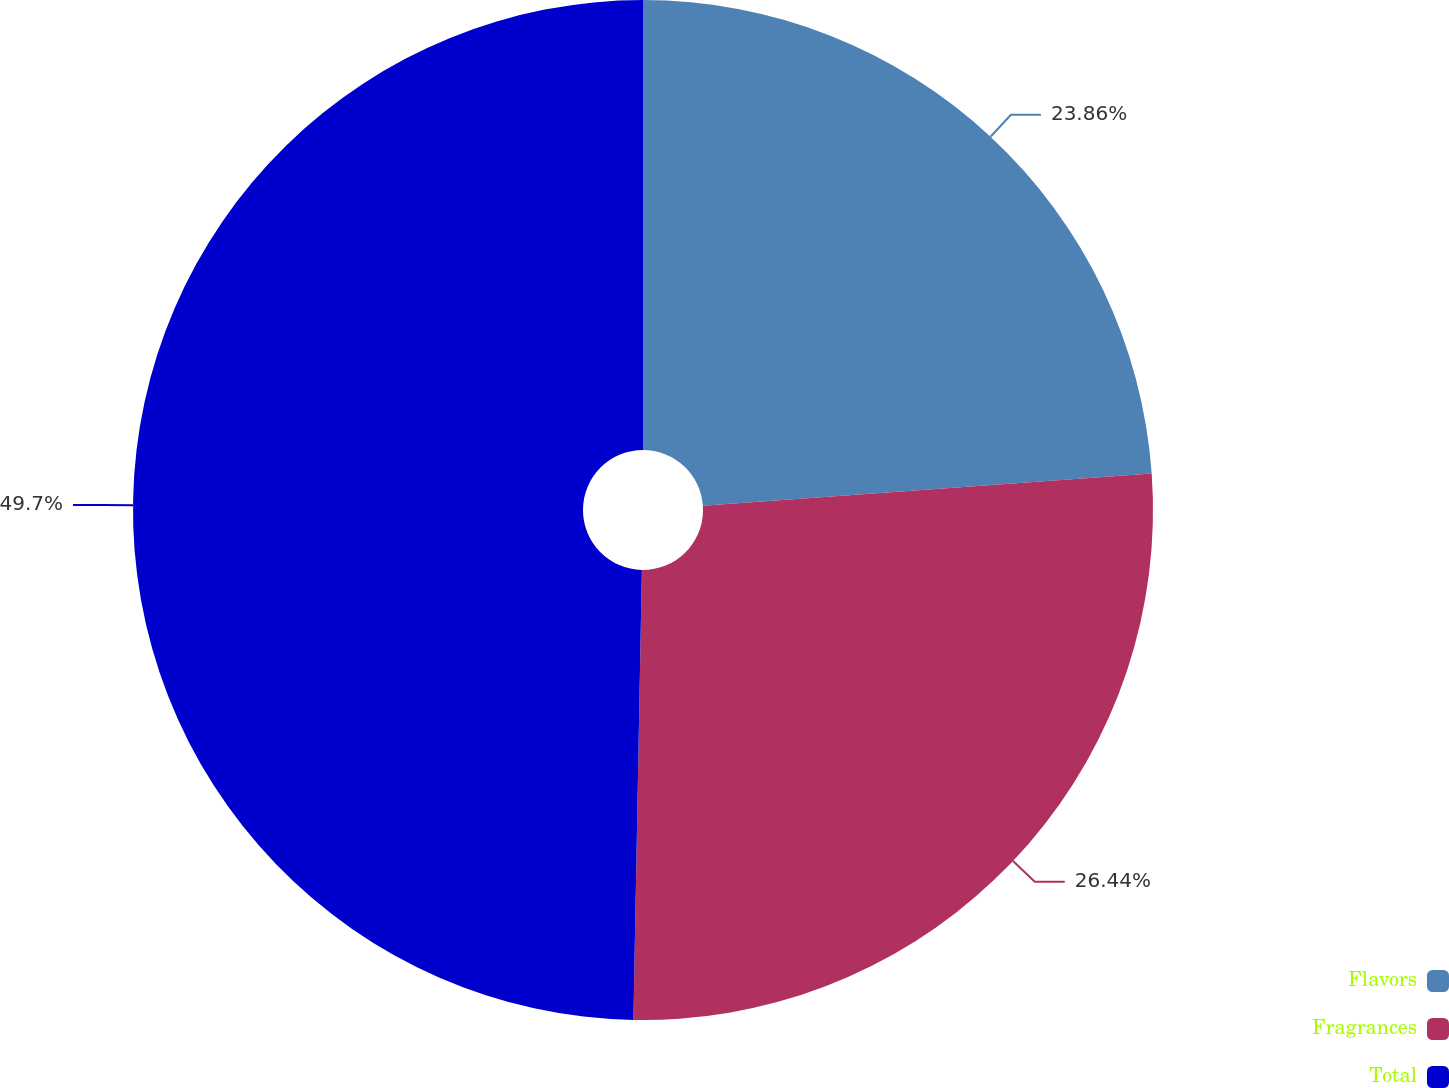Convert chart to OTSL. <chart><loc_0><loc_0><loc_500><loc_500><pie_chart><fcel>Flavors<fcel>Fragrances<fcel>Total<nl><fcel>23.86%<fcel>26.44%<fcel>49.7%<nl></chart> 